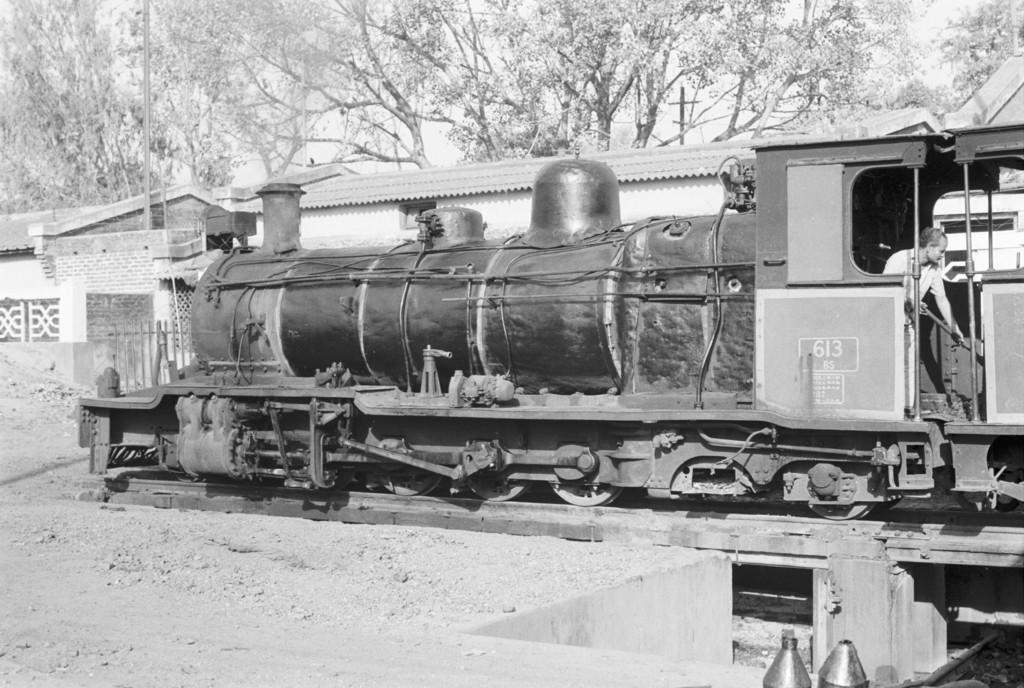What is the color scheme of the image? The image is black and white. What is the main subject of the image? There is a train in the image. Where is the train located in the image? The train is on a track. What can be seen in the background of the image? There are seeds and trees in the background of the image. What type of machine can be heard operating in the background of the image? There is no machine present or operating in the background of the image, as it is a black and white image of a train on a track with seeds and trees in the background. 